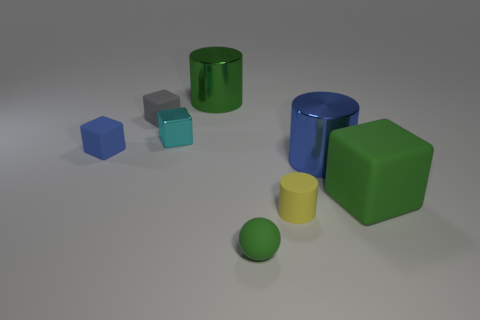Is there a big brown rubber thing that has the same shape as the cyan metallic object?
Keep it short and to the point. No. Are there any other things that are the same shape as the green metallic object?
Ensure brevity in your answer.  Yes. What material is the cylinder that is left of the green matte thing that is to the left of the green rubber thing on the right side of the small cylinder made of?
Offer a very short reply. Metal. Are there any brown matte cylinders of the same size as the green block?
Offer a very short reply. No. The metallic cylinder in front of the big cylinder behind the large blue shiny thing is what color?
Give a very brief answer. Blue. What number of big yellow matte cylinders are there?
Provide a succinct answer. 0. Do the small metal object and the ball have the same color?
Ensure brevity in your answer.  No. Is the number of large green cylinders that are to the right of the gray cube less than the number of small green rubber things that are on the right side of the big green metallic cylinder?
Make the answer very short. No. The tiny matte cylinder has what color?
Provide a short and direct response. Yellow. How many small shiny things have the same color as the matte ball?
Make the answer very short. 0. 